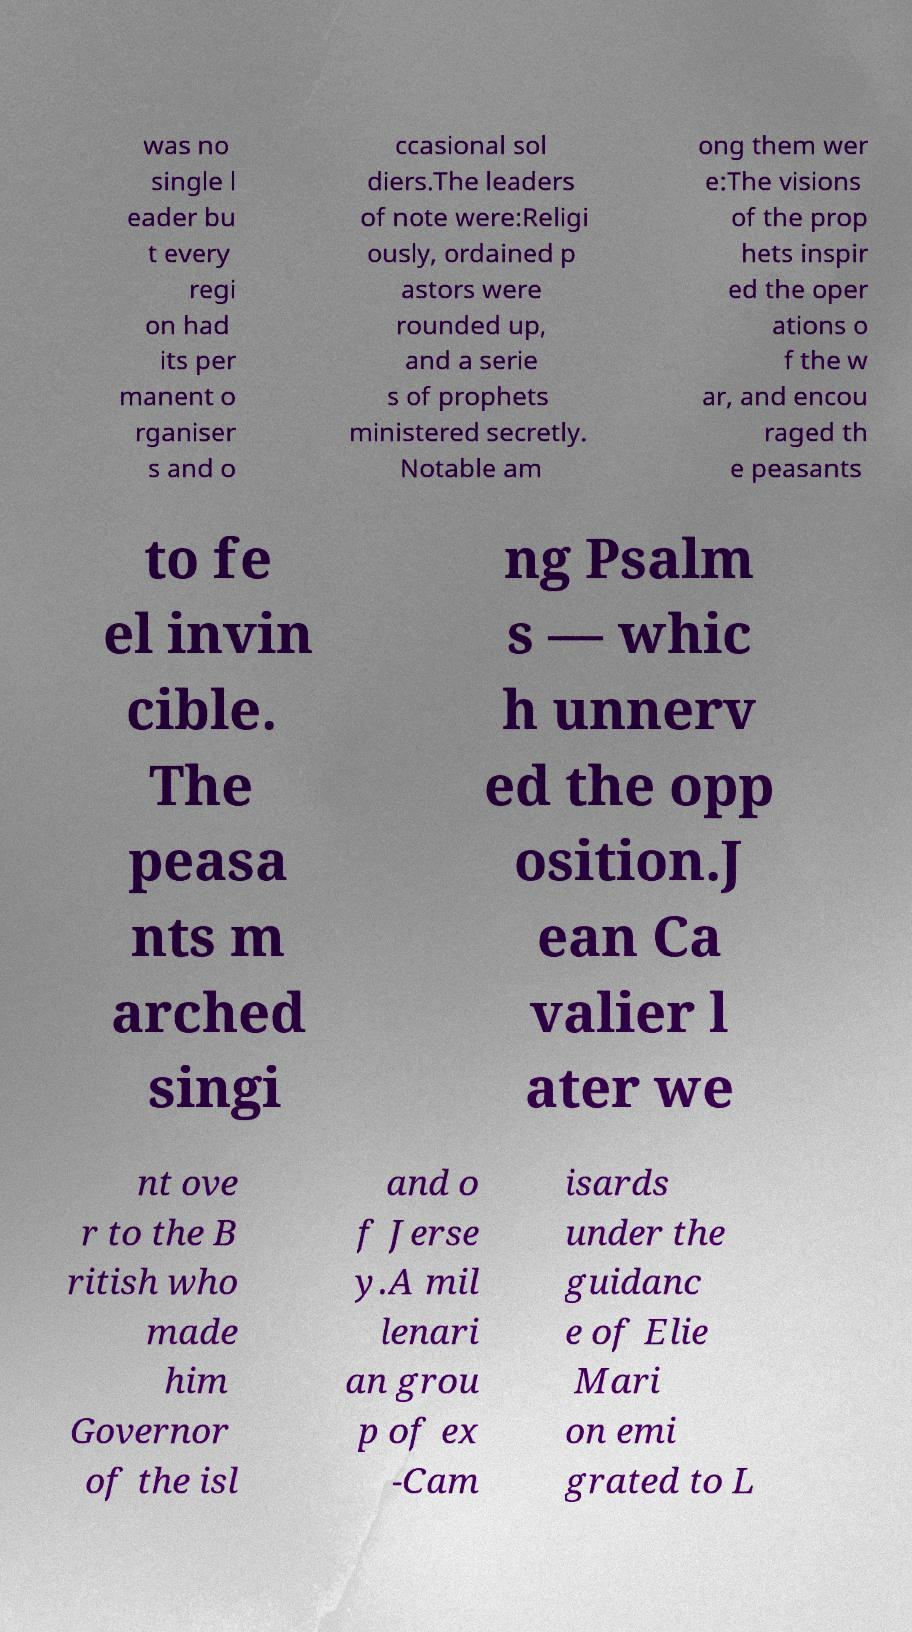There's text embedded in this image that I need extracted. Can you transcribe it verbatim? was no single l eader bu t every regi on had its per manent o rganiser s and o ccasional sol diers.The leaders of note were:Religi ously, ordained p astors were rounded up, and a serie s of prophets ministered secretly. Notable am ong them wer e:The visions of the prop hets inspir ed the oper ations o f the w ar, and encou raged th e peasants to fe el invin cible. The peasa nts m arched singi ng Psalm s — whic h unnerv ed the opp osition.J ean Ca valier l ater we nt ove r to the B ritish who made him Governor of the isl and o f Jerse y.A mil lenari an grou p of ex -Cam isards under the guidanc e of Elie Mari on emi grated to L 